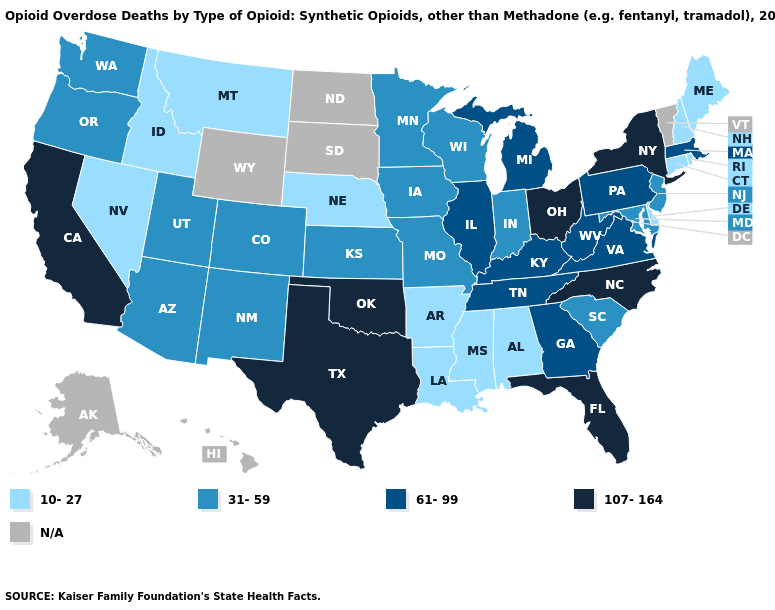What is the highest value in states that border Tennessee?
Be succinct. 107-164. Does Indiana have the highest value in the USA?
Be succinct. No. Name the states that have a value in the range 31-59?
Keep it brief. Arizona, Colorado, Indiana, Iowa, Kansas, Maryland, Minnesota, Missouri, New Jersey, New Mexico, Oregon, South Carolina, Utah, Washington, Wisconsin. What is the value of Hawaii?
Keep it brief. N/A. What is the value of New Hampshire?
Answer briefly. 10-27. What is the lowest value in states that border Colorado?
Give a very brief answer. 10-27. Among the states that border Ohio , which have the highest value?
Concise answer only. Kentucky, Michigan, Pennsylvania, West Virginia. What is the highest value in the Northeast ?
Concise answer only. 107-164. What is the lowest value in the Northeast?
Quick response, please. 10-27. What is the value of Texas?
Keep it brief. 107-164. What is the value of Illinois?
Be succinct. 61-99. Does the map have missing data?
Give a very brief answer. Yes. Does Arizona have the highest value in the West?
Concise answer only. No. Does the map have missing data?
Answer briefly. Yes. 